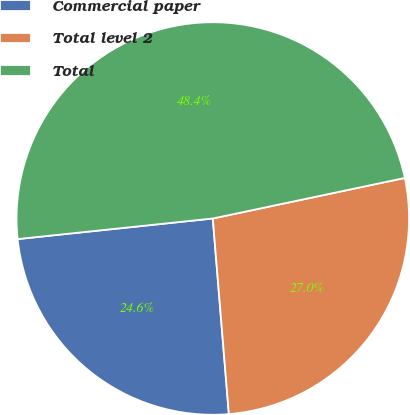Convert chart. <chart><loc_0><loc_0><loc_500><loc_500><pie_chart><fcel>Commercial paper<fcel>Total level 2<fcel>Total<nl><fcel>24.63%<fcel>27.01%<fcel>48.36%<nl></chart> 